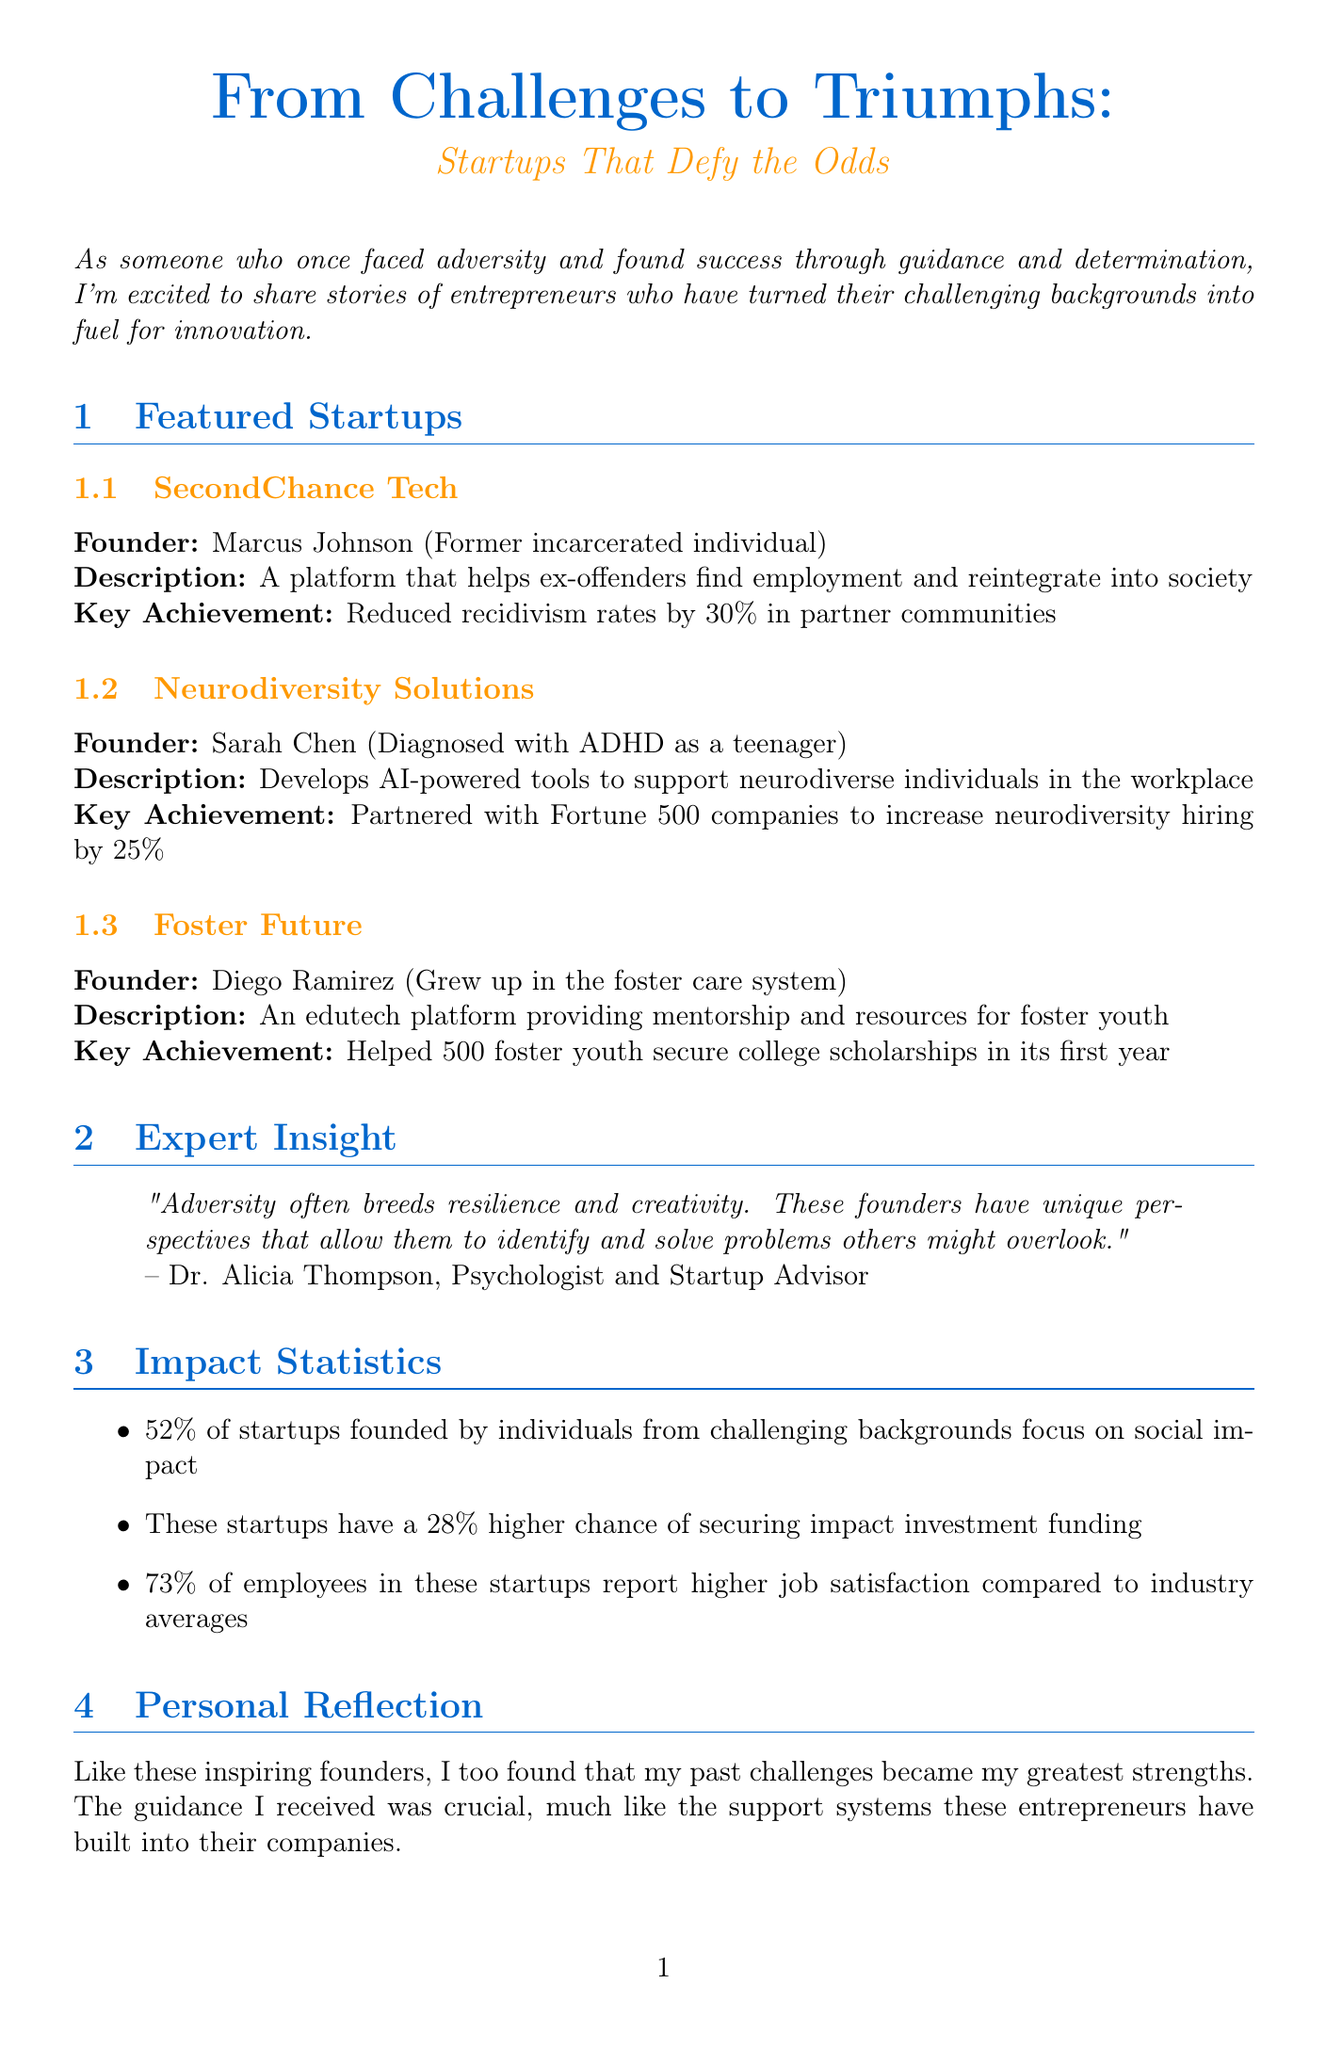What is the title of the newsletter? The title of the newsletter is provided at the beginning of the document, which is "From Challenges to Triumphs: Startups That Defy the Odds".
Answer: From Challenges to Triumphs: Startups That Defy the Odds Who is the founder of SecondChance Tech? The document specifically lists Marcus Johnson as the founder of SecondChance Tech.
Answer: Marcus Johnson What percentage of startups founded by individuals from challenging backgrounds focus on social impact? The document states that 52% of startups founded by individuals from challenging backgrounds focus on social impact.
Answer: 52% What key achievement is associated with Foster Future? The document mentions that Foster Future helped 500 foster youth secure college scholarships in its first year as its key achievement.
Answer: Helped 500 foster youth secure college scholarships in its first year Which psychologist provided insight in the newsletter? The newsletter cites Dr. Alicia Thompson, a psychologist and startup advisor, as the source of insight.
Answer: Dr. Alicia Thompson What type of tools does Neurodiversity Solutions develop? The document describes Neurodiversity Solutions as developing AI-powered tools.
Answer: AI-powered tools How many times higher is the chance of securing impact investment funding for these startups? According to the document, these startups have a 28% higher chance of securing impact investment funding.
Answer: 28% What is the purpose of the Rising Tide Foundation? The document indicates that the Rising Tide Foundation offers grants and mentorship to entrepreneurs from disadvantaged backgrounds.
Answer: Offers grants and mentorship What is one resource listed to support challenging backgrounds? The newsletter provides several resources, one being the Resilient Startup Podcast, which focuses on interviews with founders.
Answer: Resilient Startup Podcast 